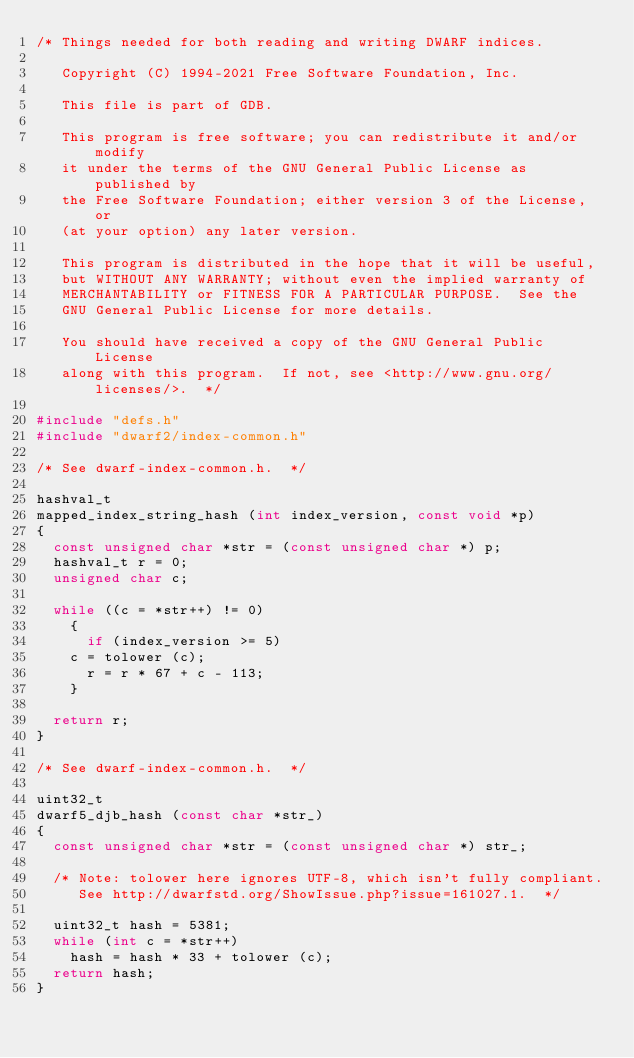Convert code to text. <code><loc_0><loc_0><loc_500><loc_500><_C_>/* Things needed for both reading and writing DWARF indices.

   Copyright (C) 1994-2021 Free Software Foundation, Inc.

   This file is part of GDB.

   This program is free software; you can redistribute it and/or modify
   it under the terms of the GNU General Public License as published by
   the Free Software Foundation; either version 3 of the License, or
   (at your option) any later version.

   This program is distributed in the hope that it will be useful,
   but WITHOUT ANY WARRANTY; without even the implied warranty of
   MERCHANTABILITY or FITNESS FOR A PARTICULAR PURPOSE.  See the
   GNU General Public License for more details.

   You should have received a copy of the GNU General Public License
   along with this program.  If not, see <http://www.gnu.org/licenses/>.  */

#include "defs.h"
#include "dwarf2/index-common.h"

/* See dwarf-index-common.h.  */

hashval_t
mapped_index_string_hash (int index_version, const void *p)
{
  const unsigned char *str = (const unsigned char *) p;
  hashval_t r = 0;
  unsigned char c;

  while ((c = *str++) != 0)
    {
      if (index_version >= 5)
	c = tolower (c);
      r = r * 67 + c - 113;
    }

  return r;
}

/* See dwarf-index-common.h.  */

uint32_t
dwarf5_djb_hash (const char *str_)
{
  const unsigned char *str = (const unsigned char *) str_;

  /* Note: tolower here ignores UTF-8, which isn't fully compliant.
     See http://dwarfstd.org/ShowIssue.php?issue=161027.1.  */

  uint32_t hash = 5381;
  while (int c = *str++)
    hash = hash * 33 + tolower (c);
  return hash;
}
</code> 